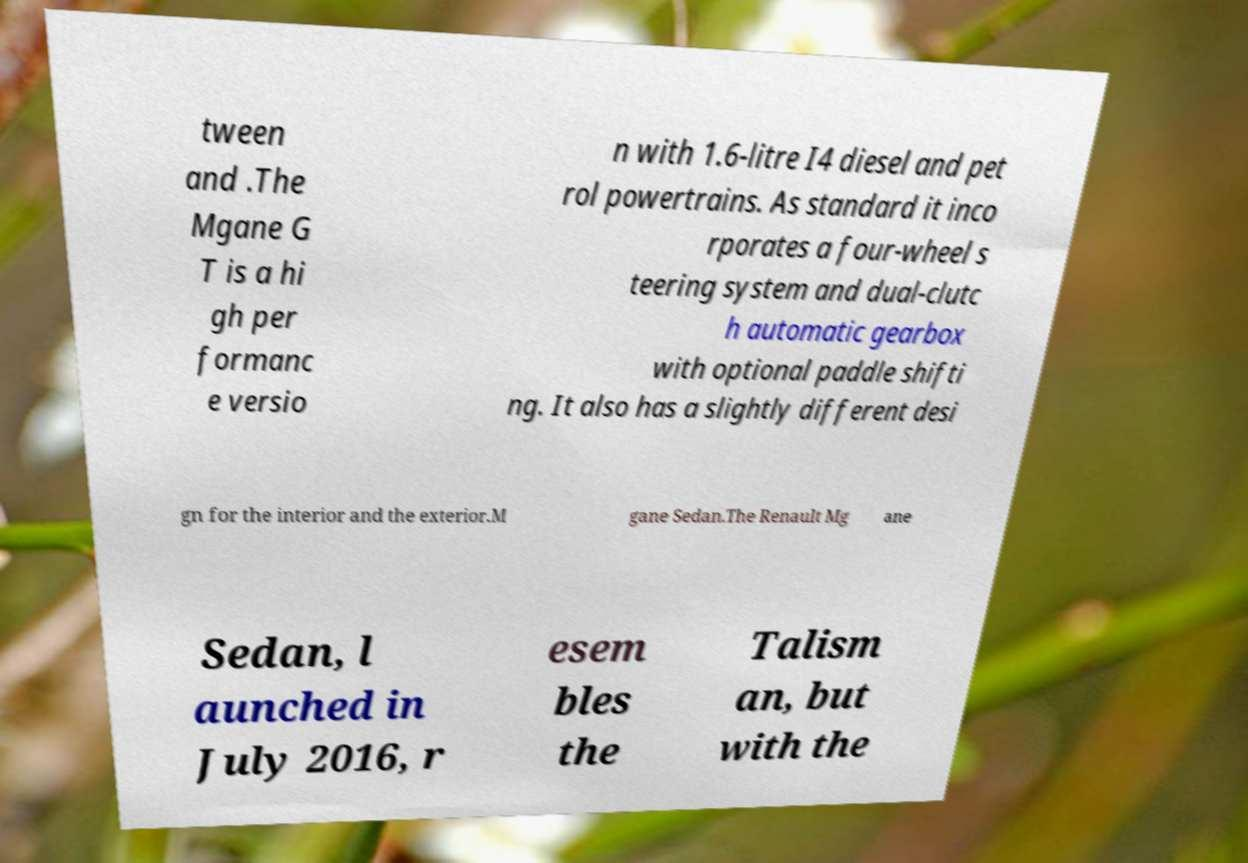For documentation purposes, I need the text within this image transcribed. Could you provide that? tween and .The Mgane G T is a hi gh per formanc e versio n with 1.6-litre I4 diesel and pet rol powertrains. As standard it inco rporates a four-wheel s teering system and dual-clutc h automatic gearbox with optional paddle shifti ng. It also has a slightly different desi gn for the interior and the exterior.M gane Sedan.The Renault Mg ane Sedan, l aunched in July 2016, r esem bles the Talism an, but with the 